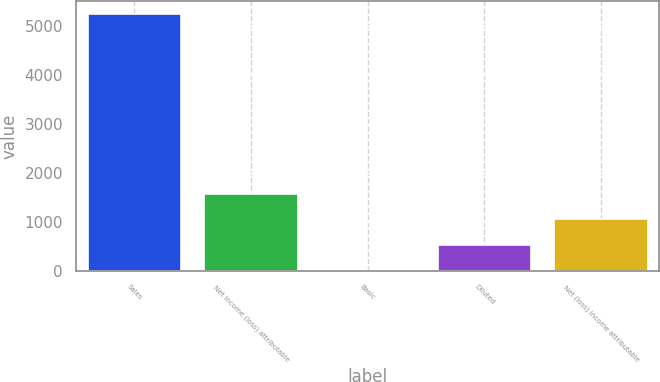Convert chart to OTSL. <chart><loc_0><loc_0><loc_500><loc_500><bar_chart><fcel>Sales<fcel>Net income (loss) attributable<fcel>Basic<fcel>Diluted<fcel>Net (loss) income attributable<nl><fcel>5245<fcel>1573.89<fcel>0.55<fcel>525<fcel>1049.45<nl></chart> 